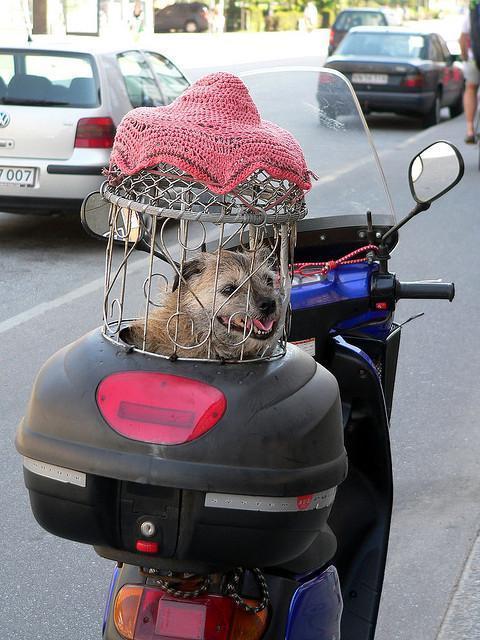How many suitcases are there?
Give a very brief answer. 0. How many cars are there?
Give a very brief answer. 2. How many dogs are visible?
Give a very brief answer. 1. 